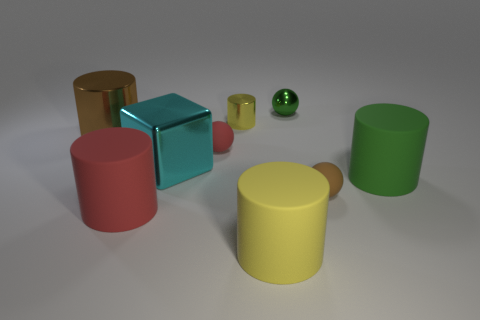Do the metal block and the small cylinder have the same color?
Your answer should be very brief. No. How many objects are big things that are to the right of the small green thing or yellow cylinders?
Make the answer very short. 3. There is a tiny cylinder on the left side of the brown ball to the right of the big yellow object; what number of tiny shiny objects are behind it?
Offer a very short reply. 1. Is there anything else that is the same size as the metallic ball?
Your answer should be very brief. Yes. There is a large metallic thing right of the big cylinder behind the large shiny object that is in front of the small red matte object; what shape is it?
Provide a short and direct response. Cube. How many other objects are there of the same color as the large shiny cylinder?
Offer a very short reply. 1. The metal object that is in front of the brown object on the left side of the big yellow object is what shape?
Ensure brevity in your answer.  Cube. What number of tiny green spheres are behind the small yellow thing?
Ensure brevity in your answer.  1. Is there a green ball that has the same material as the big brown cylinder?
Keep it short and to the point. Yes. What material is the brown thing that is the same size as the yellow matte thing?
Your answer should be very brief. Metal. 